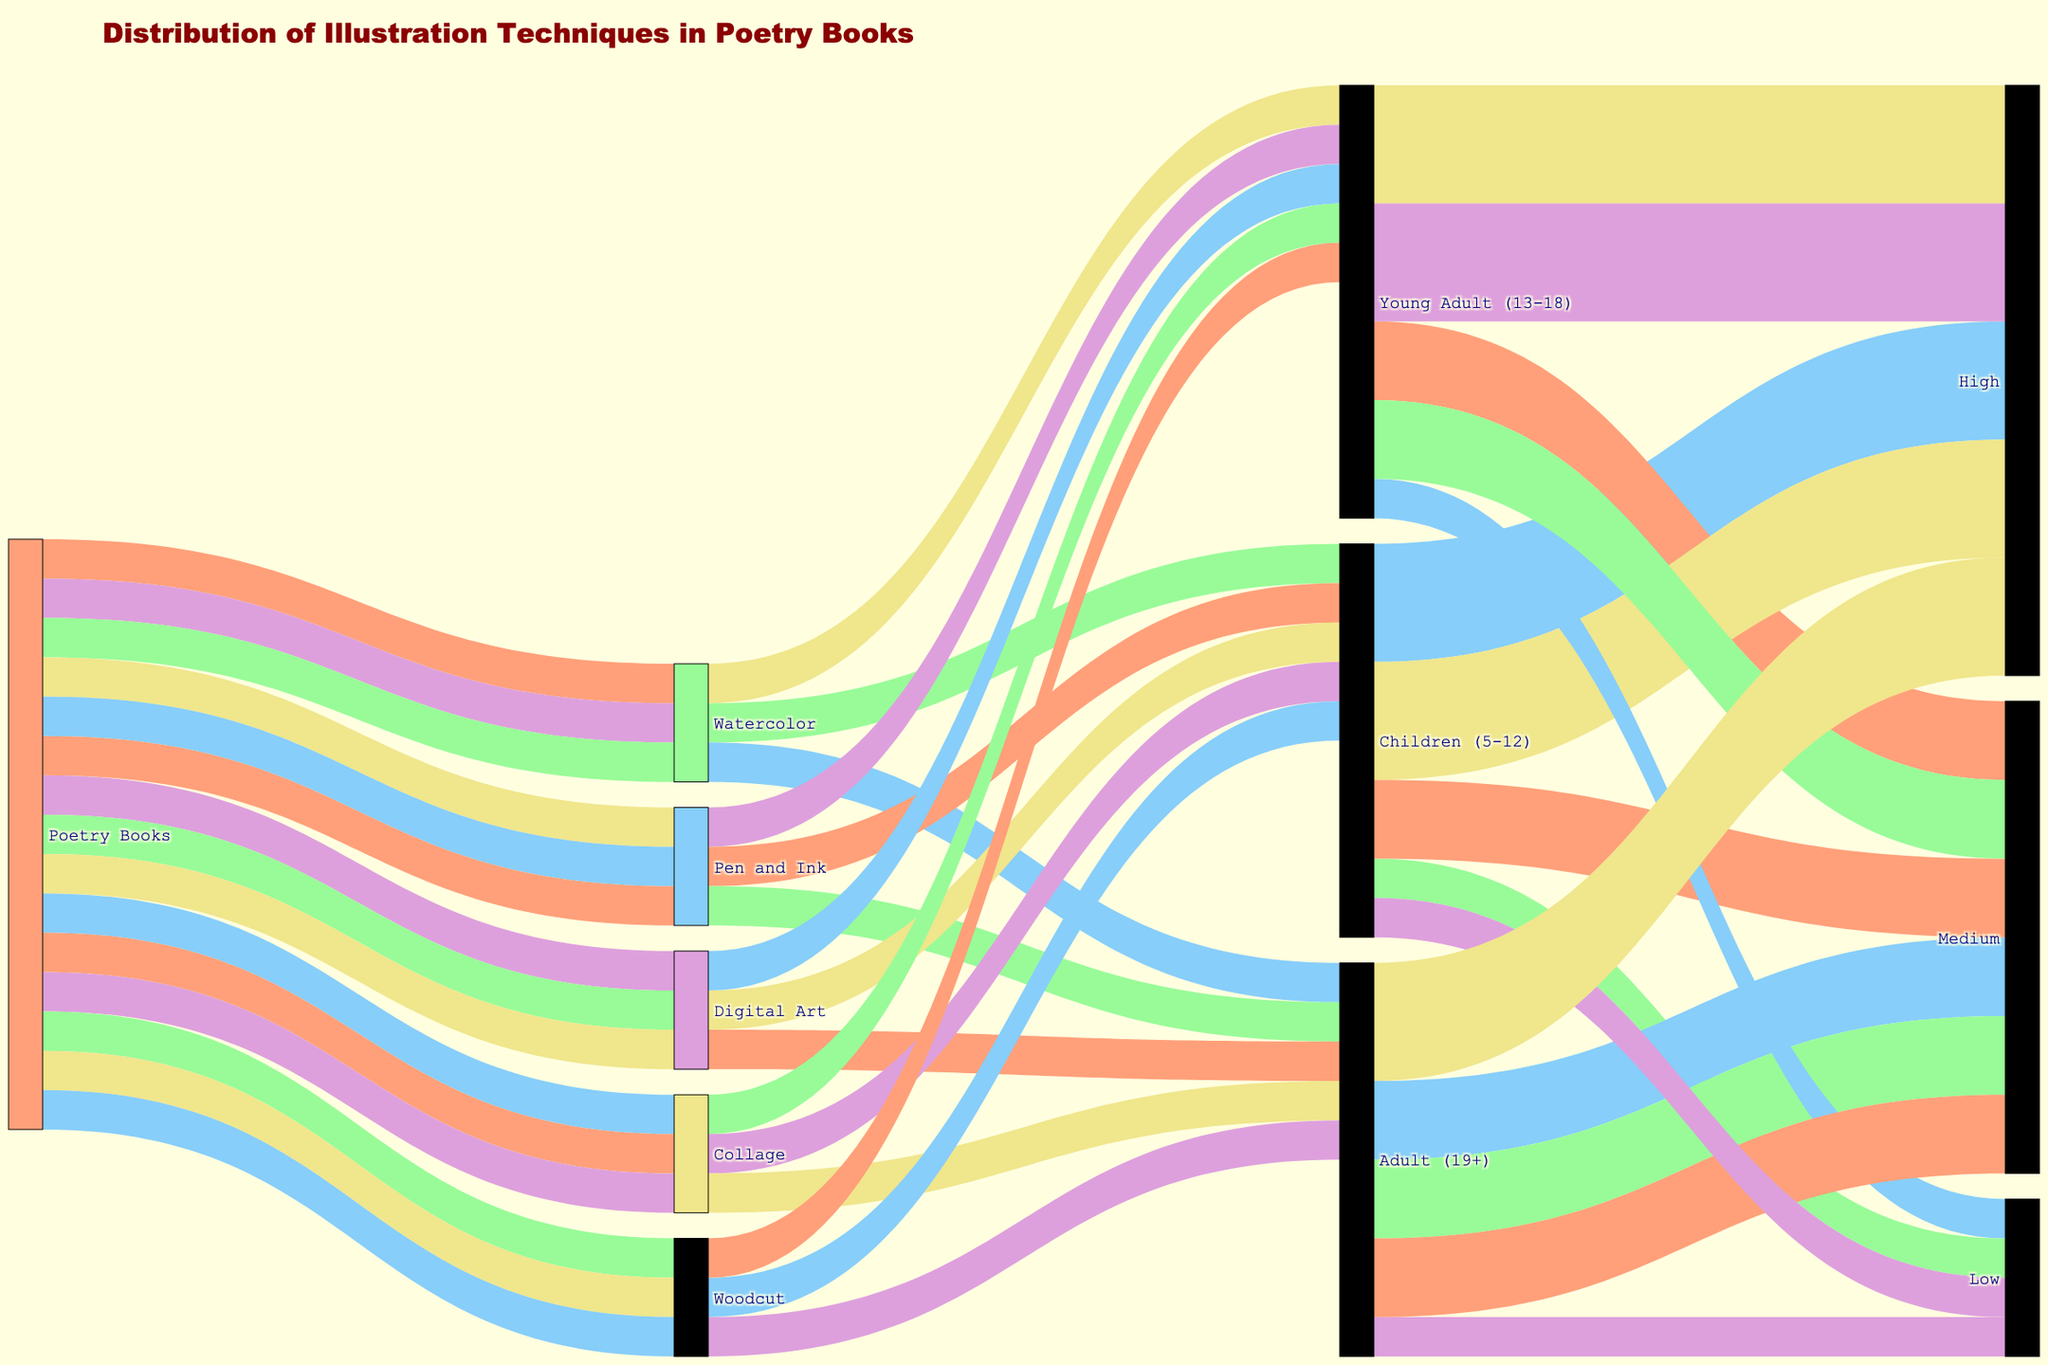What is the title of the Sankey diagram? The title is usually displayed prominently at the top of the figure. Here, it reads "Distribution of Illustration Techniques in Poetry Books".
Answer: Distribution of Illustration Techniques in Poetry Books Which illustration technique has the highest sales impact for children (5-12) age group? To determine this, look for the flow connecting "Children (5-12)" to the "Sales Impact" group. The largest flow indicates the highest impact, which connects to "High" for the Watercolor and Collage techniques.
Answer: Watercolor and Collage What color represents the target node "Young Adult (13-18)" in the diagram? The color of the nodes can be identified by looking at the node itself or the links connected to it. Here, "Young Adult (13-18)" node is represented in '#87CEFA' which corresponds to a light blue color.
Answer: Light blue Which age group has the highest sales impact on "Watercolor" technique? Trace the flows from the "Watercolor" node to the "Sales Impact" nodes through different age groups. The largest flow for "Watercolor" technique to "High" sales impact is for the "Children (5-12)" age group.
Answer: Children (5-12) How many distinct illustration techniques are represented in the figure? Count the number of unique techniques listed in the "Technique" section of the diagram: Watercolor, Pen and Ink, Digital Art, Collage, and Woodcut.
Answer: 5 What have the strongest positive sales impact in the "Young Adult (13-18)" age group? Follow the links from "Young Adult (13-18)" connecting to the "Sales Impact" nodes. The highest impact corresponds to the "High" sales impact for Pen and Ink and Digital Art techniques.
Answer: Pen and Ink and Digital Art Determine the proportion of sales impacts (‘High’, ‘Medium’, 'Low') for "Digital Art" across all age groups? Observe the flows from "Digital Art" to different age groups and then their connections to "Sales Impact". Digital Art has: High (1), Medium (2), and Low (0).
Answer: High: 1, Medium: 2, Low: 0 Which age group and technique combination appears the least often in "High" sales impact category? Determine the combination by tracking the smallest flows or absence of flows to "High" sales impact; for "High" it’s Young Adult (13-18) with Collage.
Answer: Young Adult (13-18) with Collage What is the number of age groups that have "Medium" sales impact for Watercolor? Follow the flows for "Watercolor" to "Medium" sales impact nodes. There’s one for Young Adult (13-18) and none others, resulting in one age group.
Answer: 1 